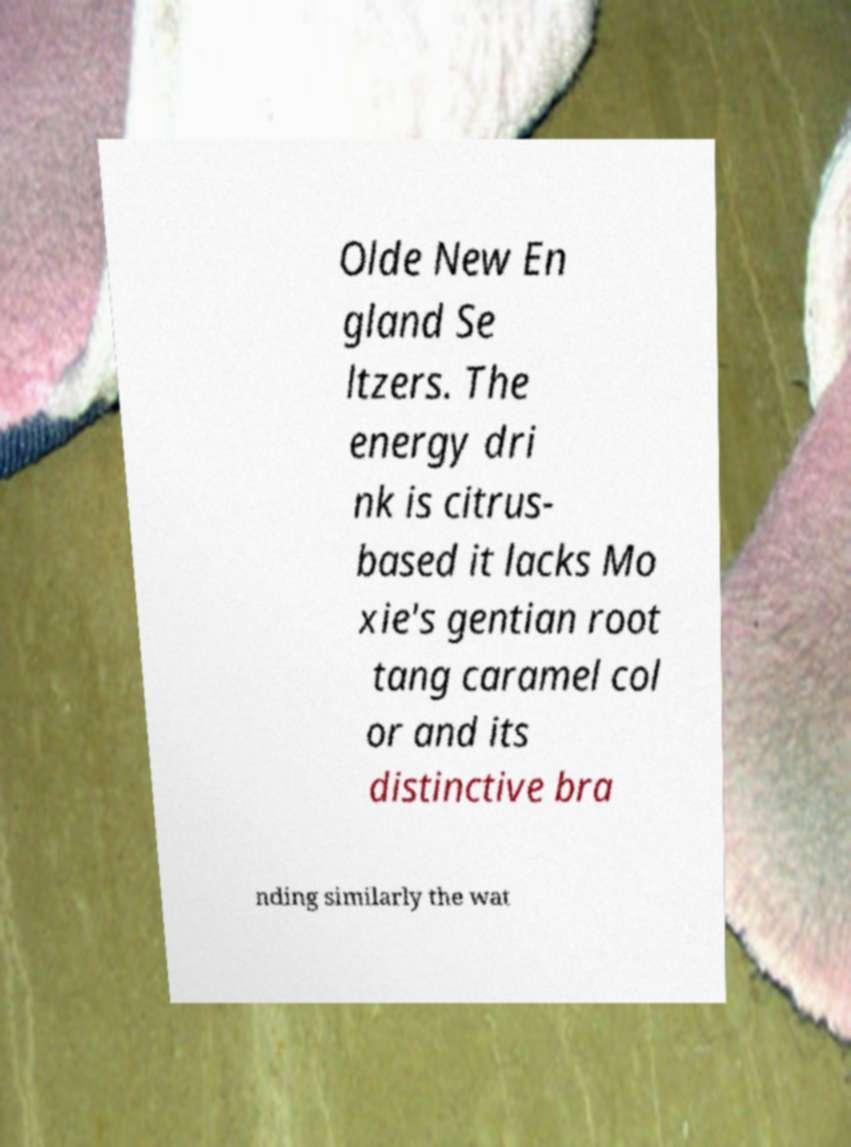Please identify and transcribe the text found in this image. Olde New En gland Se ltzers. The energy dri nk is citrus- based it lacks Mo xie's gentian root tang caramel col or and its distinctive bra nding similarly the wat 